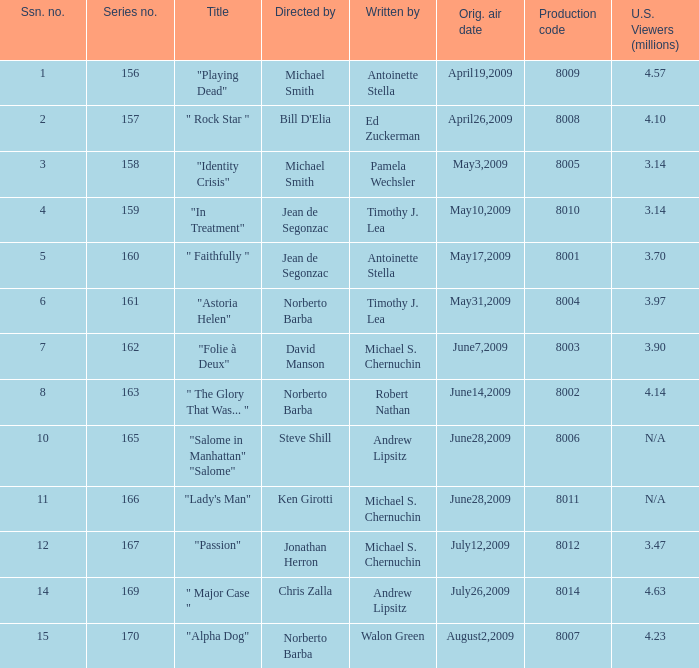Which is the biggest production code? 8014.0. Could you parse the entire table? {'header': ['Ssn. no.', 'Series no.', 'Title', 'Directed by', 'Written by', 'Orig. air date', 'Production code', 'U.S. Viewers (millions)'], 'rows': [['1', '156', '"Playing Dead"', 'Michael Smith', 'Antoinette Stella', 'April19,2009', '8009', '4.57'], ['2', '157', '" Rock Star "', "Bill D'Elia", 'Ed Zuckerman', 'April26,2009', '8008', '4.10'], ['3', '158', '"Identity Crisis"', 'Michael Smith', 'Pamela Wechsler', 'May3,2009', '8005', '3.14'], ['4', '159', '"In Treatment"', 'Jean de Segonzac', 'Timothy J. Lea', 'May10,2009', '8010', '3.14'], ['5', '160', '" Faithfully "', 'Jean de Segonzac', 'Antoinette Stella', 'May17,2009', '8001', '3.70'], ['6', '161', '"Astoria Helen"', 'Norberto Barba', 'Timothy J. Lea', 'May31,2009', '8004', '3.97'], ['7', '162', '"Folie à Deux"', 'David Manson', 'Michael S. Chernuchin', 'June7,2009', '8003', '3.90'], ['8', '163', '" The Glory That Was... "', 'Norberto Barba', 'Robert Nathan', 'June14,2009', '8002', '4.14'], ['10', '165', '"Salome in Manhattan" "Salome"', 'Steve Shill', 'Andrew Lipsitz', 'June28,2009', '8006', 'N/A'], ['11', '166', '"Lady\'s Man"', 'Ken Girotti', 'Michael S. Chernuchin', 'June28,2009', '8011', 'N/A'], ['12', '167', '"Passion"', 'Jonathan Herron', 'Michael S. Chernuchin', 'July12,2009', '8012', '3.47'], ['14', '169', '" Major Case "', 'Chris Zalla', 'Andrew Lipsitz', 'July26,2009', '8014', '4.63'], ['15', '170', '"Alpha Dog"', 'Norberto Barba', 'Walon Green', 'August2,2009', '8007', '4.23']]} 